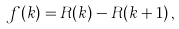Convert formula to latex. <formula><loc_0><loc_0><loc_500><loc_500>f ( k ) = R ( k ) - R ( k + 1 ) \, ,</formula> 